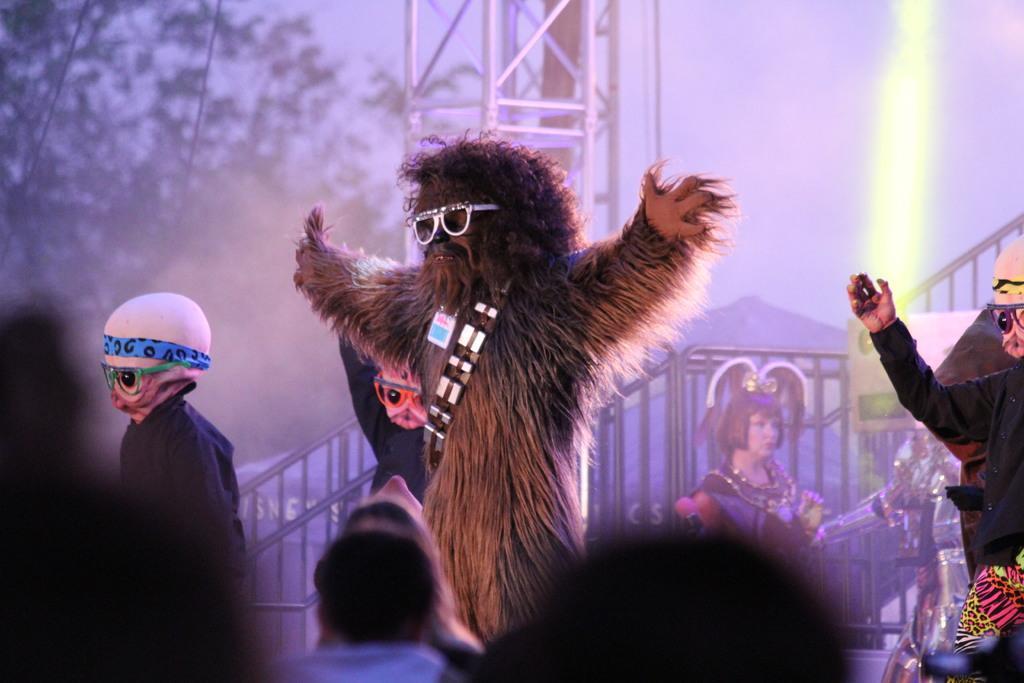In one or two sentences, can you explain what this image depicts? In the image in the center, we can see a few people are standing and they are in different costumes. In the bottom of the image, we can see a few people. In the background there is a screen and pole type structure. In the screen, we can see trees, fences and one person. 